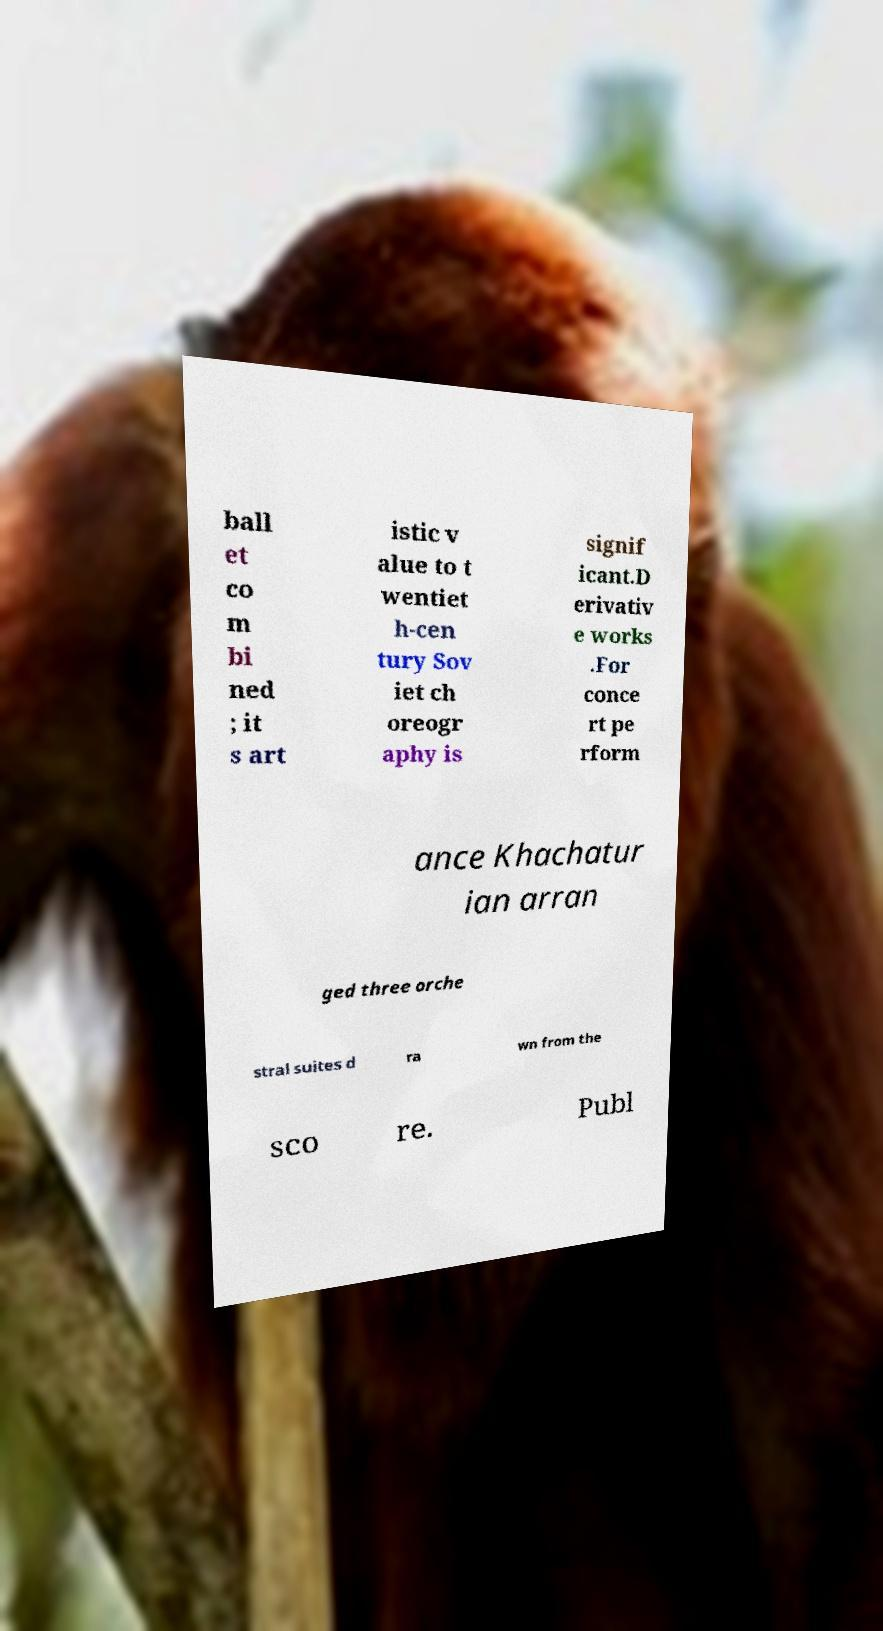Can you accurately transcribe the text from the provided image for me? ball et co m bi ned ; it s art istic v alue to t wentiet h-cen tury Sov iet ch oreogr aphy is signif icant.D erivativ e works .For conce rt pe rform ance Khachatur ian arran ged three orche stral suites d ra wn from the sco re. Publ 